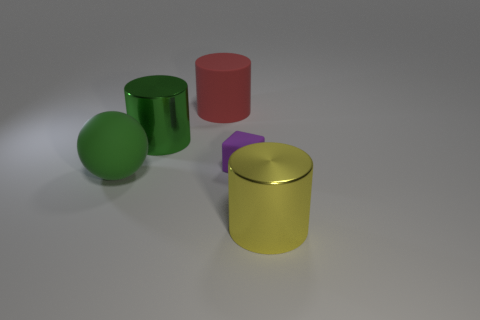What number of small yellow things are there?
Offer a very short reply. 0. There is a large yellow thing; does it have the same shape as the big shiny object behind the large green rubber ball?
Provide a succinct answer. Yes. Are there fewer green objects that are to the right of the big sphere than green metallic cylinders that are right of the green shiny object?
Offer a very short reply. No. Are there any other things that are the same shape as the small object?
Your answer should be compact. No. Is the green metal object the same shape as the small rubber thing?
Your answer should be very brief. No. Is there any other thing that is made of the same material as the cube?
Make the answer very short. Yes. The yellow cylinder is what size?
Provide a succinct answer. Large. The big thing that is to the right of the green rubber thing and in front of the purple block is what color?
Your answer should be compact. Yellow. Is the number of green matte cylinders greater than the number of things?
Provide a short and direct response. No. How many things are spheres or shiny cylinders in front of the small purple thing?
Make the answer very short. 2. 